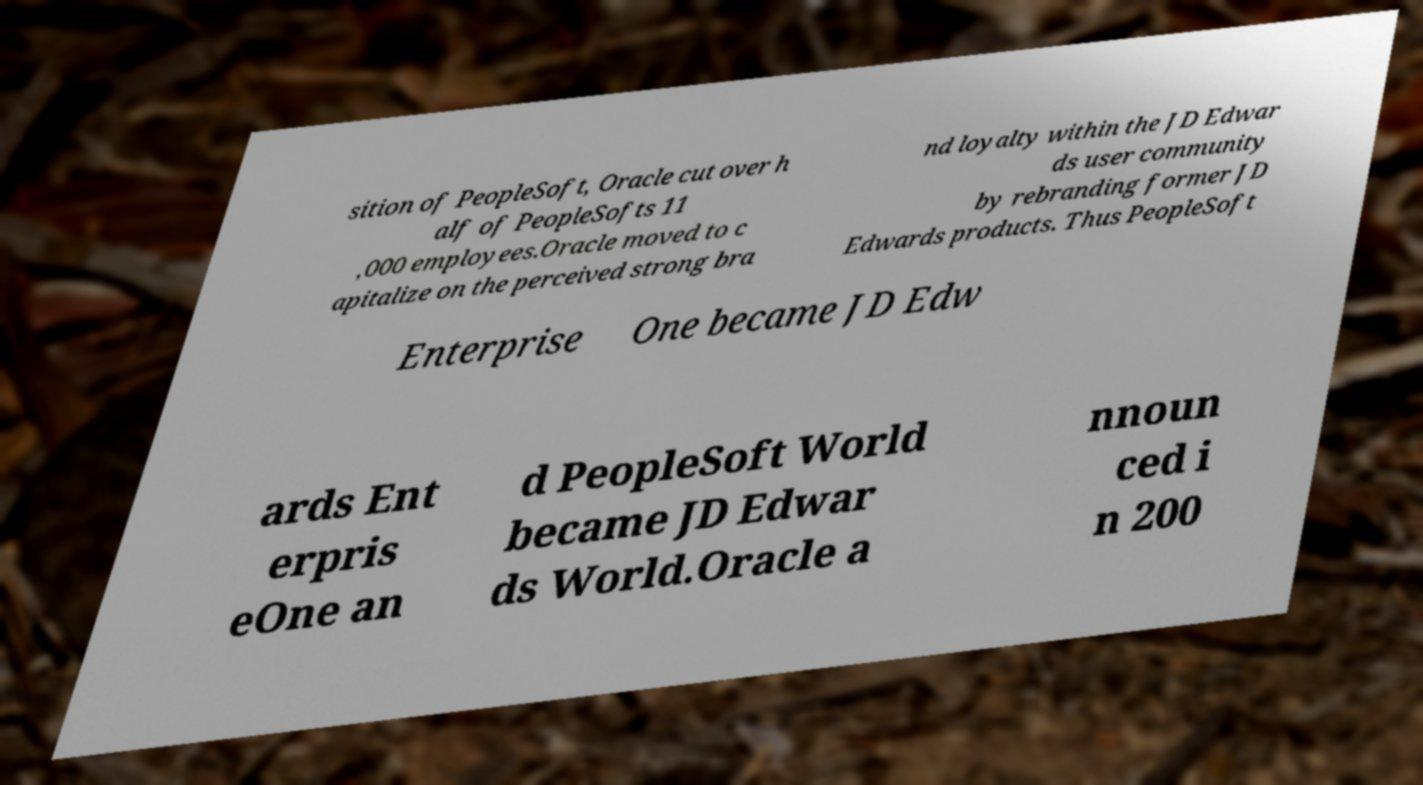For documentation purposes, I need the text within this image transcribed. Could you provide that? sition of PeopleSoft, Oracle cut over h alf of PeopleSofts 11 ,000 employees.Oracle moved to c apitalize on the perceived strong bra nd loyalty within the JD Edwar ds user community by rebranding former JD Edwards products. Thus PeopleSoft Enterprise One became JD Edw ards Ent erpris eOne an d PeopleSoft World became JD Edwar ds World.Oracle a nnoun ced i n 200 